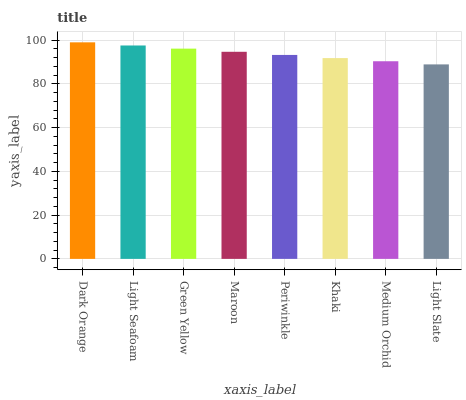Is Light Seafoam the minimum?
Answer yes or no. No. Is Light Seafoam the maximum?
Answer yes or no. No. Is Dark Orange greater than Light Seafoam?
Answer yes or no. Yes. Is Light Seafoam less than Dark Orange?
Answer yes or no. Yes. Is Light Seafoam greater than Dark Orange?
Answer yes or no. No. Is Dark Orange less than Light Seafoam?
Answer yes or no. No. Is Maroon the high median?
Answer yes or no. Yes. Is Periwinkle the low median?
Answer yes or no. Yes. Is Medium Orchid the high median?
Answer yes or no. No. Is Khaki the low median?
Answer yes or no. No. 